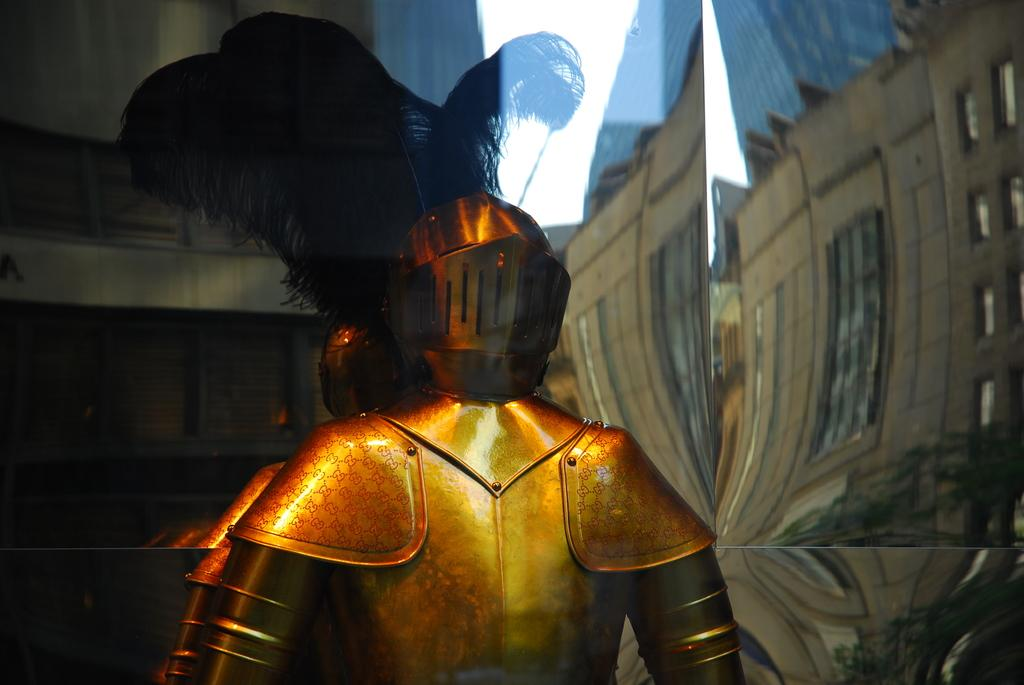What type of clothing is depicted in the image? There is a human warrior dress in the image. What material is the dress made of? The dress is made up of stainless steel. How is the dress displayed in the image? The dress is inside a glass. What type of toothpaste is the warrior using in the image? There is no toothpaste or any indication of personal hygiene in the image; it features a stainless steel warrior dress inside a glass. 